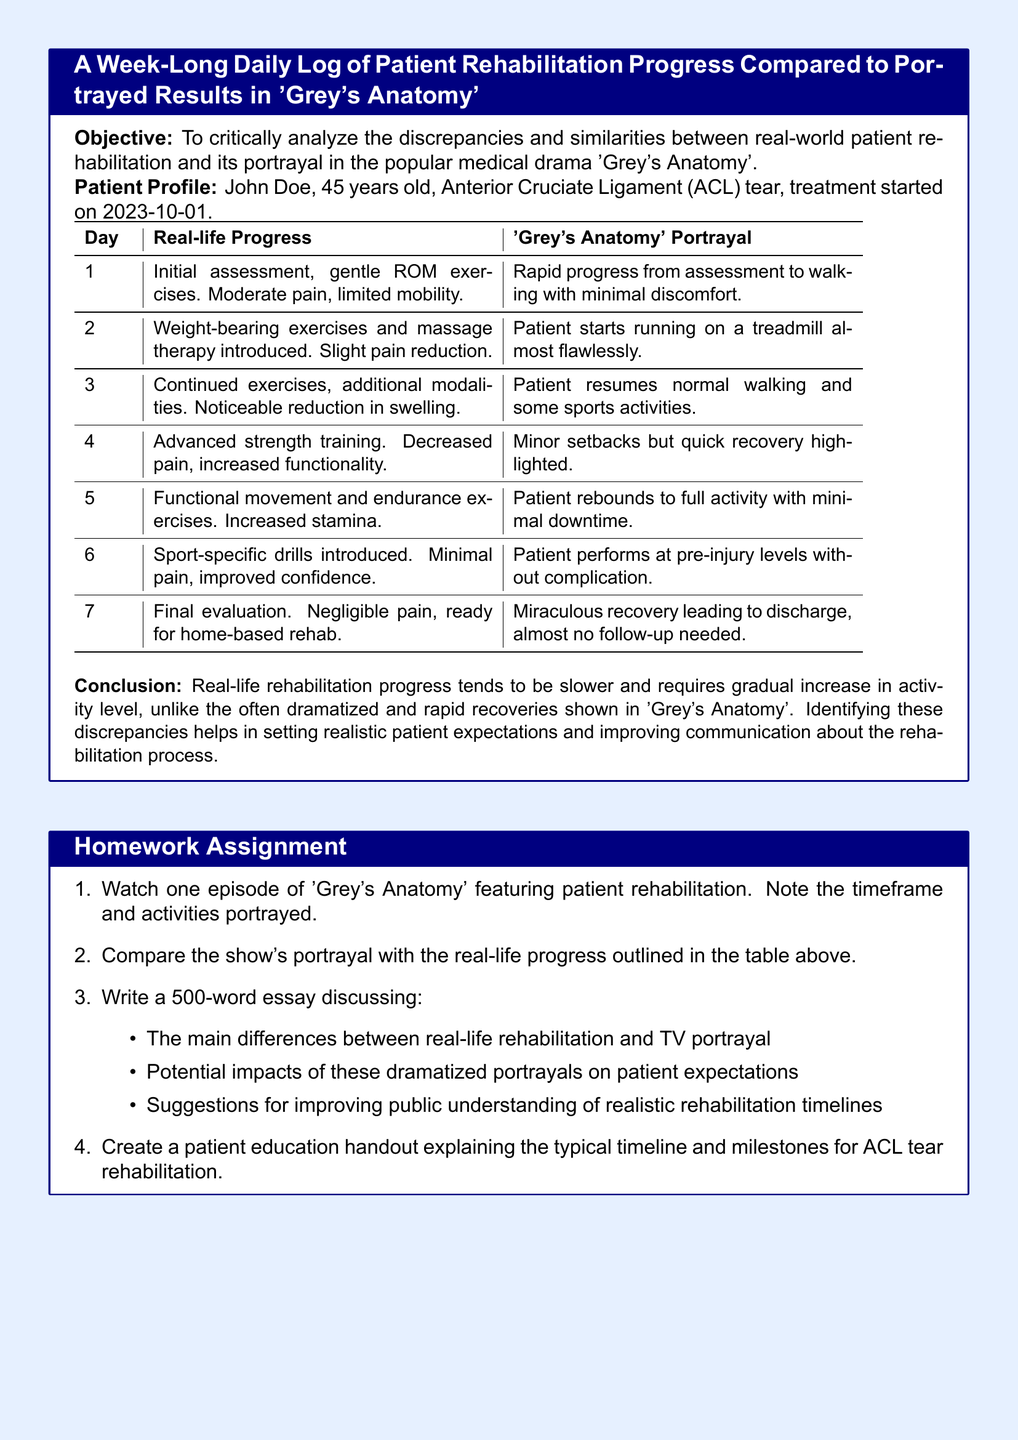What is the patient's name? The document provides a patient profile which states the name is John Doe.
Answer: John Doe What is the injury sustained by the patient? The patient profile specifies an Anterior Cruciate Ligament (ACL) tear as the injury.
Answer: ACL tear On what date did the treatment start? The initial assessment date is noted as 2023-10-01.
Answer: 2023-10-01 What was the patient's condition on Day 1? The log indicates that the patient had moderate pain and limited mobility.
Answer: Moderate pain, limited mobility What activity was introduced on Day 2? The log mentions that weight-bearing exercises and massage therapy were introduced on Day 2.
Answer: Weight-bearing exercises and massage therapy What is a major difference between real-life rehabilitation and the portrayal in 'Grey's Anatomy'? The conclusion outlines that real-life rehabilitation is slower and more gradual compared to the dramatized rapid recoveries shown in the program.
Answer: Slower and more gradual What milestone is achieved on Day 7? The log states that on Day 7, the patient has negligible pain and is ready for home-based rehab.
Answer: Ready for home-based rehab What is required in the homework assignment's essay discussion? The assignment specifically requests discussion on the differences between real-life rehabilitation and TV portrayal, among other points.
Answer: Main differences, potential impacts, suggestions How long should the essay be? The homework assignment specifies that the essay should be 500 words long.
Answer: 500 words 